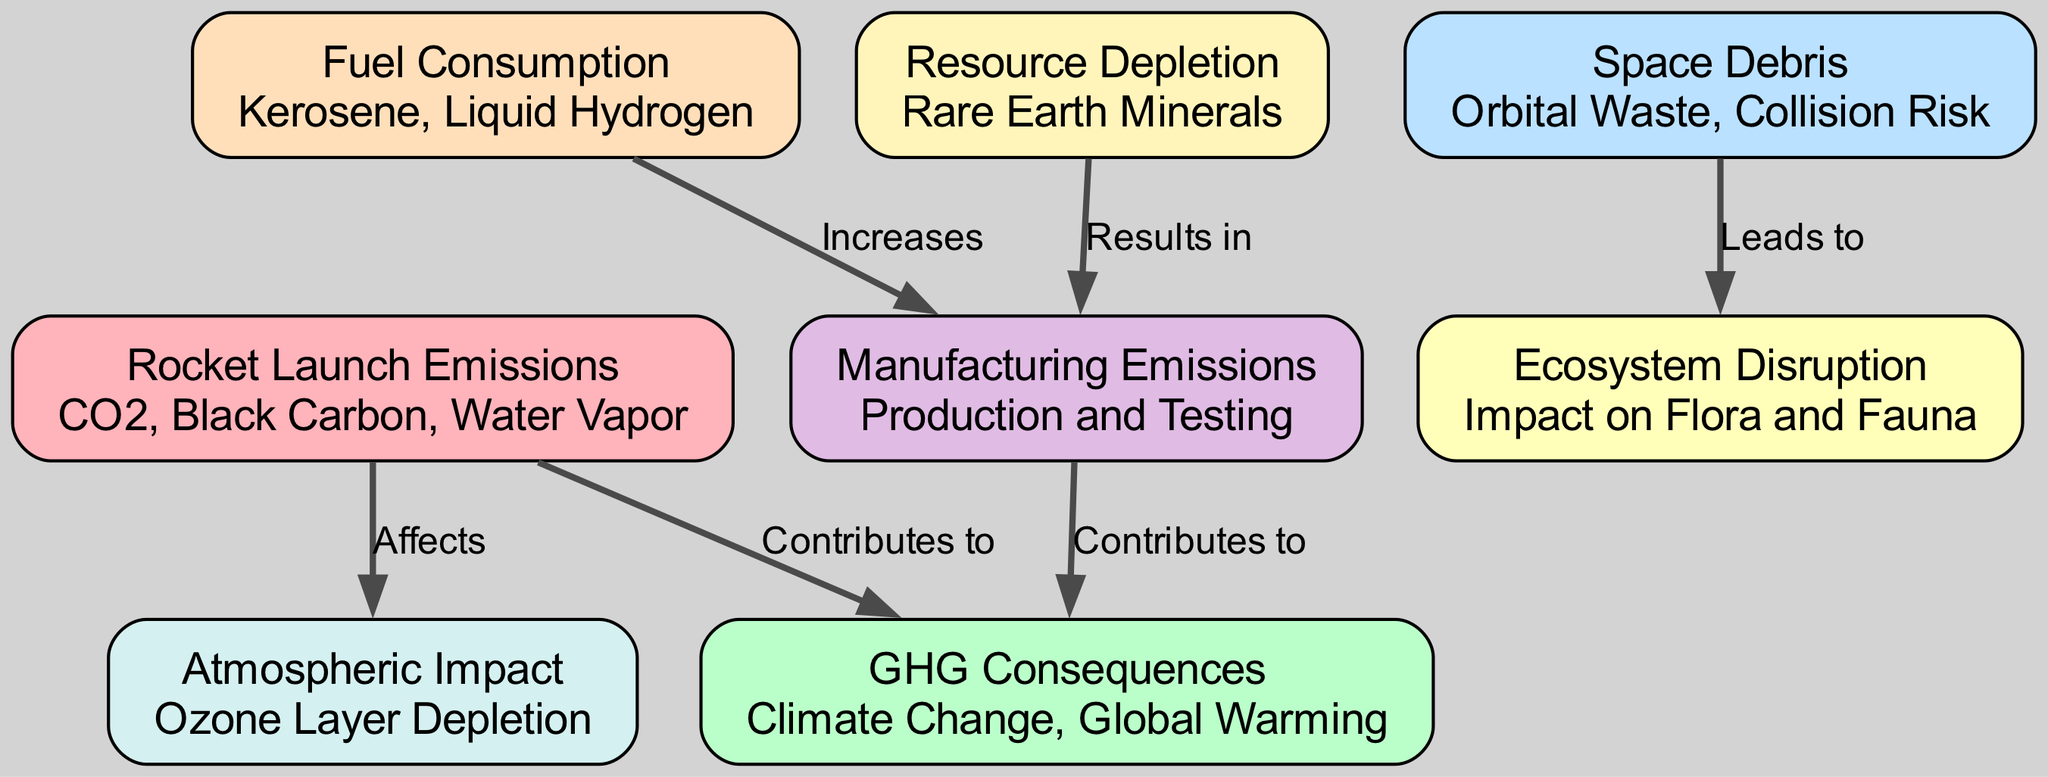What's the total number of nodes in the diagram? The diagram contains eight distinct nodes, each representing different aspects related to the environmental cost of space travel and tourism.
Answer: 8 How many edges are connecting the nodes? There are six edges in the diagram, representing the relationships and interactions between the different nodes regarding environmental impacts.
Answer: 6 What does 'rocket launch emissions' contribute to? The 'rocket launch emissions' node directly leads to 'GHG Consequences' and 'atmospheric impact', indicating it contributes to climate change and ozone layer depletion.
Answer: GHG Consequences Which node is affected by rocket launch emissions? The 'atmospheric impact' node is affected by the 'rocket launch emissions', as represented by a directed edge showing that emissions can deplete the ozone layer.
Answer: Atmospheric Impact What outcome does the 'space debris' lead to? The 'space debris' node leads to 'ecosystem disruption', suggesting that debris in space results in negative impacts on ecosystems on Earth.
Answer: Ecosystem Disruption What impact does fuel consumption have on manufacturing emissions? The 'fuel consumption' node increases 'manufacturing emissions', indicating that more fuel usage during manufacturing processes contributes to higher emissions.
Answer: Increases How does resource depletion relate to manufacturing emissions? 'Resource depletion' results in increased 'manufacturing emissions', implying that the lack of rare earth minerals raises the emissions during the production and testing of rockets.
Answer: Results in What two consequences are linked to rocket launch emissions? The two consequences directly linked to 'rocket launch emissions' are 'GHG Consequences' and 'atmospheric impact', showing a clear connection to climate and atmospheric issues.
Answer: Climate Change, Ozone Layer Depletion What type of waste is associated with 'space debris'? The 'space debris' node describes itself as 'orbital waste', which encompasses the various discarded objects in Earth's orbit that can pose risks to other spacecraft and satellites.
Answer: Orbital Waste 